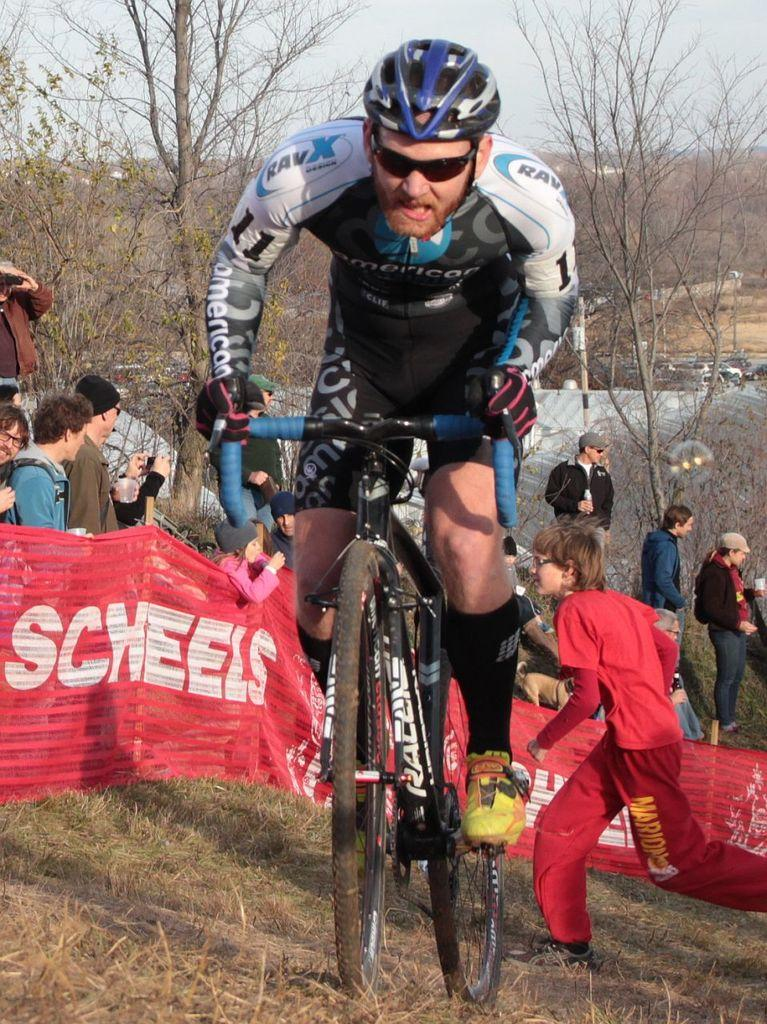How many people are in the image? There is a group of people in the image. What is one person in the group doing? One person is cycling. What can be seen in the background of the image? There are trees and vehicles in the background of the image. What type of lock can be seen on the fang of the person cycling in the image? There is no lock or fang present in the image; it features a group of people, one of whom is cycling. 